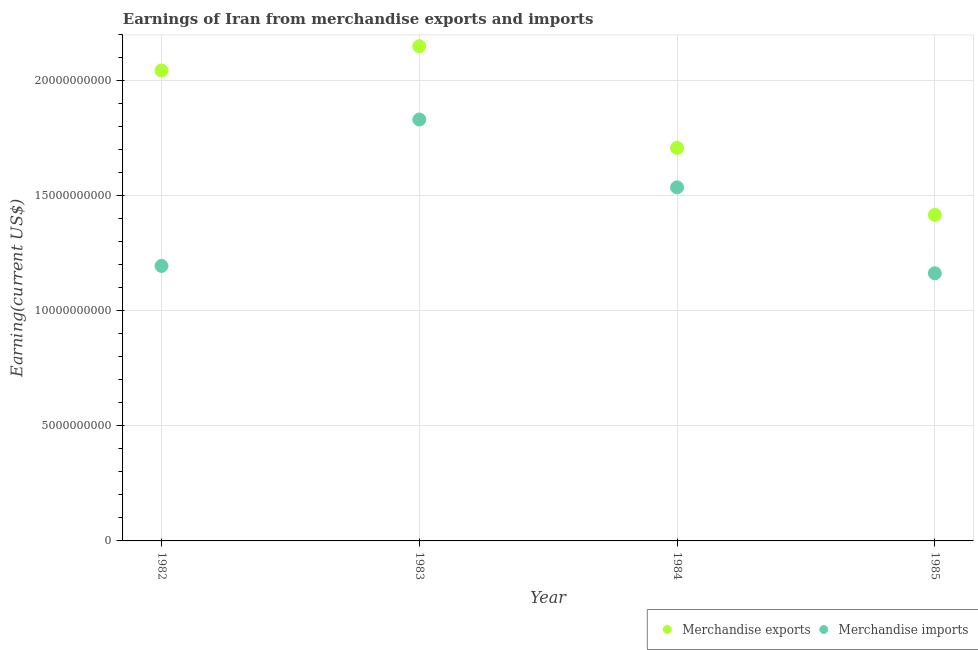What is the earnings from merchandise imports in 1983?
Your response must be concise. 1.83e+1. Across all years, what is the maximum earnings from merchandise exports?
Make the answer very short. 2.15e+1. Across all years, what is the minimum earnings from merchandise imports?
Provide a succinct answer. 1.16e+1. In which year was the earnings from merchandise imports maximum?
Ensure brevity in your answer.  1983. What is the total earnings from merchandise imports in the graph?
Your answer should be very brief. 5.73e+1. What is the difference between the earnings from merchandise imports in 1983 and that in 1985?
Your answer should be compact. 6.68e+09. What is the difference between the earnings from merchandise imports in 1983 and the earnings from merchandise exports in 1984?
Offer a terse response. 1.23e+09. What is the average earnings from merchandise imports per year?
Keep it short and to the point. 1.43e+1. In the year 1983, what is the difference between the earnings from merchandise exports and earnings from merchandise imports?
Your answer should be compact. 3.19e+09. What is the ratio of the earnings from merchandise imports in 1983 to that in 1984?
Provide a short and direct response. 1.19. Is the earnings from merchandise exports in 1982 less than that in 1983?
Provide a succinct answer. Yes. Is the difference between the earnings from merchandise imports in 1983 and 1984 greater than the difference between the earnings from merchandise exports in 1983 and 1984?
Make the answer very short. No. What is the difference between the highest and the second highest earnings from merchandise exports?
Your answer should be compact. 1.06e+09. What is the difference between the highest and the lowest earnings from merchandise imports?
Offer a terse response. 6.68e+09. Is the sum of the earnings from merchandise exports in 1982 and 1983 greater than the maximum earnings from merchandise imports across all years?
Give a very brief answer. Yes. Does the earnings from merchandise exports monotonically increase over the years?
Make the answer very short. No. Is the earnings from merchandise exports strictly less than the earnings from merchandise imports over the years?
Your answer should be compact. No. How many dotlines are there?
Keep it short and to the point. 2. What is the difference between two consecutive major ticks on the Y-axis?
Give a very brief answer. 5.00e+09. Does the graph contain any zero values?
Your answer should be compact. No. Where does the legend appear in the graph?
Offer a very short reply. Bottom right. How are the legend labels stacked?
Provide a succinct answer. Horizontal. What is the title of the graph?
Provide a short and direct response. Earnings of Iran from merchandise exports and imports. Does "Diesel" appear as one of the legend labels in the graph?
Your answer should be very brief. No. What is the label or title of the X-axis?
Your answer should be compact. Year. What is the label or title of the Y-axis?
Provide a succinct answer. Earning(current US$). What is the Earning(current US$) of Merchandise exports in 1982?
Ensure brevity in your answer.  2.05e+1. What is the Earning(current US$) of Merchandise imports in 1982?
Offer a very short reply. 1.20e+1. What is the Earning(current US$) in Merchandise exports in 1983?
Ensure brevity in your answer.  2.15e+1. What is the Earning(current US$) of Merchandise imports in 1983?
Your answer should be very brief. 1.83e+1. What is the Earning(current US$) of Merchandise exports in 1984?
Your answer should be very brief. 1.71e+1. What is the Earning(current US$) in Merchandise imports in 1984?
Your answer should be compact. 1.54e+1. What is the Earning(current US$) of Merchandise exports in 1985?
Make the answer very short. 1.42e+1. What is the Earning(current US$) of Merchandise imports in 1985?
Give a very brief answer. 1.16e+1. Across all years, what is the maximum Earning(current US$) in Merchandise exports?
Give a very brief answer. 2.15e+1. Across all years, what is the maximum Earning(current US$) of Merchandise imports?
Offer a very short reply. 1.83e+1. Across all years, what is the minimum Earning(current US$) of Merchandise exports?
Make the answer very short. 1.42e+1. Across all years, what is the minimum Earning(current US$) in Merchandise imports?
Keep it short and to the point. 1.16e+1. What is the total Earning(current US$) in Merchandise exports in the graph?
Provide a short and direct response. 7.32e+1. What is the total Earning(current US$) of Merchandise imports in the graph?
Make the answer very short. 5.73e+1. What is the difference between the Earning(current US$) of Merchandise exports in 1982 and that in 1983?
Provide a succinct answer. -1.06e+09. What is the difference between the Earning(current US$) of Merchandise imports in 1982 and that in 1983?
Your answer should be compact. -6.36e+09. What is the difference between the Earning(current US$) of Merchandise exports in 1982 and that in 1984?
Offer a very short reply. 3.36e+09. What is the difference between the Earning(current US$) in Merchandise imports in 1982 and that in 1984?
Keep it short and to the point. -3.42e+09. What is the difference between the Earning(current US$) of Merchandise exports in 1982 and that in 1985?
Make the answer very short. 6.28e+09. What is the difference between the Earning(current US$) of Merchandise imports in 1982 and that in 1985?
Your answer should be compact. 3.20e+08. What is the difference between the Earning(current US$) of Merchandise exports in 1983 and that in 1984?
Offer a terse response. 4.42e+09. What is the difference between the Earning(current US$) of Merchandise imports in 1983 and that in 1984?
Give a very brief answer. 2.95e+09. What is the difference between the Earning(current US$) in Merchandise exports in 1983 and that in 1985?
Offer a very short reply. 7.33e+09. What is the difference between the Earning(current US$) in Merchandise imports in 1983 and that in 1985?
Ensure brevity in your answer.  6.68e+09. What is the difference between the Earning(current US$) of Merchandise exports in 1984 and that in 1985?
Give a very brief answer. 2.91e+09. What is the difference between the Earning(current US$) of Merchandise imports in 1984 and that in 1985?
Your response must be concise. 3.74e+09. What is the difference between the Earning(current US$) of Merchandise exports in 1982 and the Earning(current US$) of Merchandise imports in 1983?
Your response must be concise. 2.13e+09. What is the difference between the Earning(current US$) in Merchandise exports in 1982 and the Earning(current US$) in Merchandise imports in 1984?
Provide a succinct answer. 5.08e+09. What is the difference between the Earning(current US$) in Merchandise exports in 1982 and the Earning(current US$) in Merchandise imports in 1985?
Your answer should be compact. 8.82e+09. What is the difference between the Earning(current US$) in Merchandise exports in 1983 and the Earning(current US$) in Merchandise imports in 1984?
Make the answer very short. 6.14e+09. What is the difference between the Earning(current US$) in Merchandise exports in 1983 and the Earning(current US$) in Merchandise imports in 1985?
Your answer should be very brief. 9.87e+09. What is the difference between the Earning(current US$) in Merchandise exports in 1984 and the Earning(current US$) in Merchandise imports in 1985?
Offer a very short reply. 5.45e+09. What is the average Earning(current US$) in Merchandise exports per year?
Your answer should be very brief. 1.83e+1. What is the average Earning(current US$) in Merchandise imports per year?
Provide a short and direct response. 1.43e+1. In the year 1982, what is the difference between the Earning(current US$) of Merchandise exports and Earning(current US$) of Merchandise imports?
Offer a very short reply. 8.50e+09. In the year 1983, what is the difference between the Earning(current US$) of Merchandise exports and Earning(current US$) of Merchandise imports?
Ensure brevity in your answer.  3.19e+09. In the year 1984, what is the difference between the Earning(current US$) in Merchandise exports and Earning(current US$) in Merchandise imports?
Your answer should be compact. 1.72e+09. In the year 1985, what is the difference between the Earning(current US$) in Merchandise exports and Earning(current US$) in Merchandise imports?
Keep it short and to the point. 2.54e+09. What is the ratio of the Earning(current US$) of Merchandise exports in 1982 to that in 1983?
Your answer should be compact. 0.95. What is the ratio of the Earning(current US$) of Merchandise imports in 1982 to that in 1983?
Your answer should be very brief. 0.65. What is the ratio of the Earning(current US$) in Merchandise exports in 1982 to that in 1984?
Provide a short and direct response. 1.2. What is the ratio of the Earning(current US$) of Merchandise imports in 1982 to that in 1984?
Ensure brevity in your answer.  0.78. What is the ratio of the Earning(current US$) of Merchandise exports in 1982 to that in 1985?
Your answer should be compact. 1.44. What is the ratio of the Earning(current US$) of Merchandise imports in 1982 to that in 1985?
Keep it short and to the point. 1.03. What is the ratio of the Earning(current US$) in Merchandise exports in 1983 to that in 1984?
Your answer should be very brief. 1.26. What is the ratio of the Earning(current US$) of Merchandise imports in 1983 to that in 1984?
Provide a short and direct response. 1.19. What is the ratio of the Earning(current US$) in Merchandise exports in 1983 to that in 1985?
Make the answer very short. 1.52. What is the ratio of the Earning(current US$) in Merchandise imports in 1983 to that in 1985?
Your response must be concise. 1.57. What is the ratio of the Earning(current US$) in Merchandise exports in 1984 to that in 1985?
Your answer should be very brief. 1.21. What is the ratio of the Earning(current US$) in Merchandise imports in 1984 to that in 1985?
Your answer should be very brief. 1.32. What is the difference between the highest and the second highest Earning(current US$) in Merchandise exports?
Your answer should be very brief. 1.06e+09. What is the difference between the highest and the second highest Earning(current US$) in Merchandise imports?
Provide a succinct answer. 2.95e+09. What is the difference between the highest and the lowest Earning(current US$) in Merchandise exports?
Offer a terse response. 7.33e+09. What is the difference between the highest and the lowest Earning(current US$) in Merchandise imports?
Ensure brevity in your answer.  6.68e+09. 